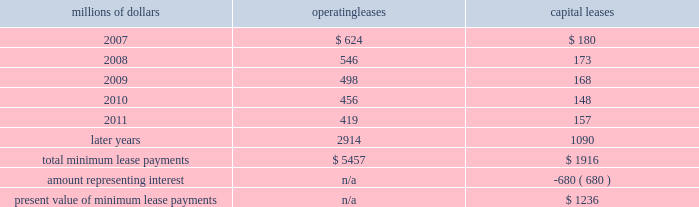Depending upon our senior unsecured debt ratings .
The facilities require the maintenance of a minimum net worth and a debt to net worth coverage ratio .
At december 31 , 2006 , we were in compliance with these covenants .
The facilities do not include any other financial restrictions , credit rating triggers ( other than rating-dependent pricing ) , or any other provision that could require the posting of collateral .
In addition to our revolving credit facilities , we had $ 150 million in uncommitted lines of credit available , including $ 75 million that expires in march 2007 and $ 75 million expiring in may 2007 .
Neither of these lines of credit were used as of december 31 , 2006 .
We must have equivalent credit available under our five-year facilities to draw on these $ 75 million lines .
Dividend restrictions 2013 we are subject to certain restrictions related to the payment of cash dividends to our shareholders due to minimum net worth requirements under the credit facilities referred to above .
The amount of retained earnings available for dividends was $ 7.8 billion and $ 6.2 billion at december 31 , 2006 and 2005 , respectively .
We do not expect that these restrictions will have a material adverse effect on our consolidated financial condition , results of operations , or liquidity .
We declared dividends of $ 323 million in 2006 and $ 316 million in 2005 .
Shelf registration statement 2013 under a current shelf registration statement , we may issue any combination of debt securities , preferred stock , common stock , or warrants for debt securities or preferred stock in one or more offerings .
At december 31 , 2006 , we had $ 500 million remaining for issuance under the current shelf registration statement .
We have no immediate plans to issue any securities ; however , we routinely consider and evaluate opportunities to replace existing debt or access capital through issuances of debt securities under this shelf registration , and , therefore , we may issue debt securities at any time .
Leases we lease certain locomotives , freight cars , and other property .
Future minimum lease payments for operating and capital leases with initial or remaining non-cancelable lease terms in excess of one year as of december 31 , 2006 were as follows : millions of dollars operating leases capital leases .
Rent expense for operating leases with terms exceeding one month was $ 798 million in 2006 , $ 728 million in 2005 , and $ 651 million in 2004 .
When cash rental payments are not made on a straight-line basis , we recognize variable rental expense on a straight-line basis over the lease term .
Contingent rentals and sub-rentals are not significant. .
As of december 2006 what was the percent of the total future minimum lease payments for operating and capital leases that was due in 2009? 
Computations: ((498 + 168) / (5457 + 1916))
Answer: 0.09033. 